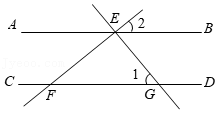Elaborate on what is shown in the illustration. The illustration features a geometric diagram with two parallel lines, AB and CD, intersected by another line, EF, at points E and F respectively. Point G is situated on the line segment CD but not at the intersection with EF as G is beyond the intersection point F along CD. This line configuration showcases a specific setup often found in problems involving properties of parallel lines and transversals as well as angle relationships such as alternate interior angles or corresponding angles. 